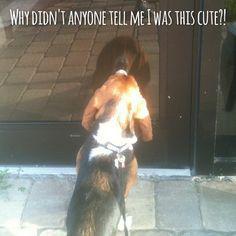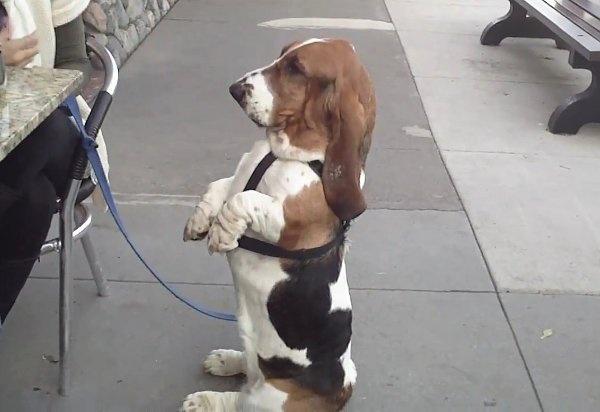The first image is the image on the left, the second image is the image on the right. Assess this claim about the two images: "The right image includes a tri-color dog in an upright profile pose with its front paws raised off the ground.". Correct or not? Answer yes or no. Yes. The first image is the image on the left, the second image is the image on the right. Analyze the images presented: Is the assertion "One of the images shows a dog with its two front paws off the ground." valid? Answer yes or no. Yes. 